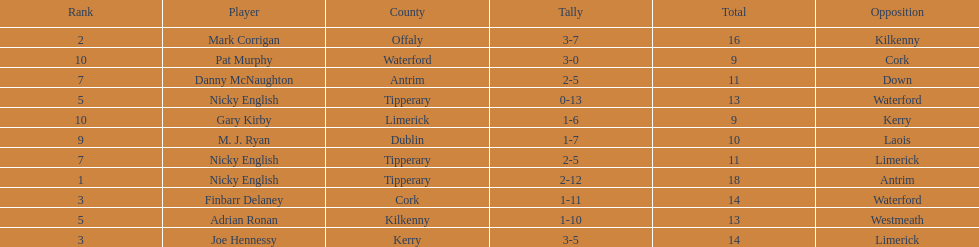Who was the top ranked player in a single game? Nicky English. 